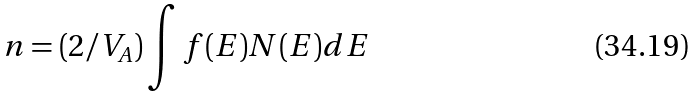Convert formula to latex. <formula><loc_0><loc_0><loc_500><loc_500>n = ( 2 / V _ { A } ) \int { f ( E ) N ( E ) d E }</formula> 